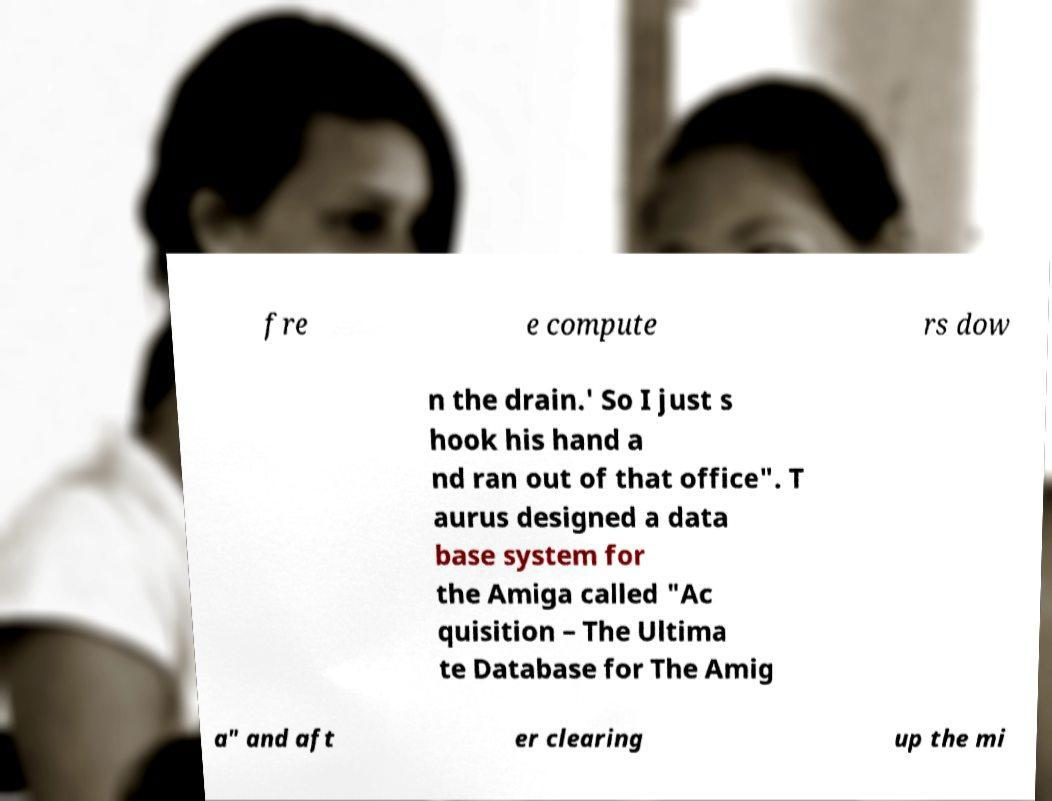Please read and relay the text visible in this image. What does it say? fre e compute rs dow n the drain.' So I just s hook his hand a nd ran out of that office". T aurus designed a data base system for the Amiga called "Ac quisition – The Ultima te Database for The Amig a" and aft er clearing up the mi 